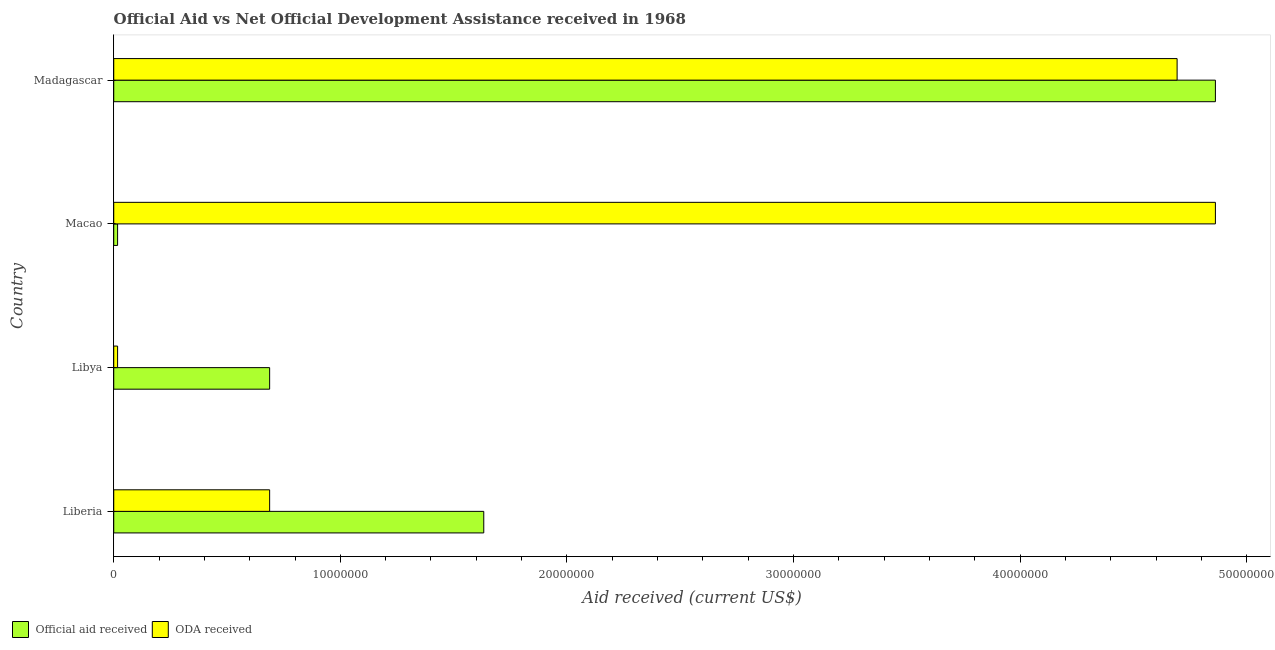Are the number of bars on each tick of the Y-axis equal?
Your answer should be compact. Yes. How many bars are there on the 4th tick from the bottom?
Make the answer very short. 2. What is the label of the 1st group of bars from the top?
Keep it short and to the point. Madagascar. In how many cases, is the number of bars for a given country not equal to the number of legend labels?
Keep it short and to the point. 0. What is the official aid received in Madagascar?
Make the answer very short. 4.86e+07. Across all countries, what is the maximum oda received?
Your response must be concise. 4.86e+07. Across all countries, what is the minimum official aid received?
Offer a very short reply. 1.70e+05. In which country was the official aid received maximum?
Make the answer very short. Madagascar. In which country was the oda received minimum?
Offer a very short reply. Libya. What is the total oda received in the graph?
Offer a terse response. 1.03e+08. What is the difference between the oda received in Liberia and that in Macao?
Your answer should be compact. -4.17e+07. What is the difference between the official aid received in Madagascar and the oda received in Liberia?
Your answer should be compact. 4.17e+07. What is the average official aid received per country?
Your answer should be very brief. 1.80e+07. What is the difference between the oda received and official aid received in Macao?
Give a very brief answer. 4.84e+07. What is the ratio of the oda received in Macao to that in Madagascar?
Offer a terse response. 1.04. Is the oda received in Liberia less than that in Libya?
Ensure brevity in your answer.  No. Is the difference between the official aid received in Liberia and Libya greater than the difference between the oda received in Liberia and Libya?
Your answer should be very brief. Yes. What is the difference between the highest and the second highest oda received?
Your answer should be compact. 1.69e+06. What is the difference between the highest and the lowest official aid received?
Make the answer very short. 4.84e+07. Is the sum of the official aid received in Macao and Madagascar greater than the maximum oda received across all countries?
Ensure brevity in your answer.  Yes. What does the 2nd bar from the top in Madagascar represents?
Offer a terse response. Official aid received. What does the 1st bar from the bottom in Madagascar represents?
Offer a terse response. Official aid received. How many bars are there?
Your response must be concise. 8. Are all the bars in the graph horizontal?
Keep it short and to the point. Yes. Are the values on the major ticks of X-axis written in scientific E-notation?
Offer a terse response. No. Does the graph contain grids?
Your answer should be compact. No. Where does the legend appear in the graph?
Your response must be concise. Bottom left. What is the title of the graph?
Keep it short and to the point. Official Aid vs Net Official Development Assistance received in 1968 . What is the label or title of the X-axis?
Make the answer very short. Aid received (current US$). What is the Aid received (current US$) of Official aid received in Liberia?
Provide a succinct answer. 1.63e+07. What is the Aid received (current US$) in ODA received in Liberia?
Your response must be concise. 6.88e+06. What is the Aid received (current US$) in Official aid received in Libya?
Keep it short and to the point. 6.88e+06. What is the Aid received (current US$) of ODA received in Macao?
Make the answer very short. 4.86e+07. What is the Aid received (current US$) of Official aid received in Madagascar?
Your answer should be compact. 4.86e+07. What is the Aid received (current US$) of ODA received in Madagascar?
Offer a terse response. 4.69e+07. Across all countries, what is the maximum Aid received (current US$) in Official aid received?
Your answer should be compact. 4.86e+07. Across all countries, what is the maximum Aid received (current US$) in ODA received?
Provide a short and direct response. 4.86e+07. Across all countries, what is the minimum Aid received (current US$) of ODA received?
Your answer should be compact. 1.70e+05. What is the total Aid received (current US$) of Official aid received in the graph?
Offer a very short reply. 7.20e+07. What is the total Aid received (current US$) of ODA received in the graph?
Offer a terse response. 1.03e+08. What is the difference between the Aid received (current US$) of Official aid received in Liberia and that in Libya?
Make the answer very short. 9.45e+06. What is the difference between the Aid received (current US$) of ODA received in Liberia and that in Libya?
Keep it short and to the point. 6.71e+06. What is the difference between the Aid received (current US$) in Official aid received in Liberia and that in Macao?
Ensure brevity in your answer.  1.62e+07. What is the difference between the Aid received (current US$) of ODA received in Liberia and that in Macao?
Ensure brevity in your answer.  -4.17e+07. What is the difference between the Aid received (current US$) of Official aid received in Liberia and that in Madagascar?
Your response must be concise. -3.23e+07. What is the difference between the Aid received (current US$) in ODA received in Liberia and that in Madagascar?
Your answer should be very brief. -4.00e+07. What is the difference between the Aid received (current US$) of Official aid received in Libya and that in Macao?
Offer a very short reply. 6.71e+06. What is the difference between the Aid received (current US$) in ODA received in Libya and that in Macao?
Provide a succinct answer. -4.84e+07. What is the difference between the Aid received (current US$) in Official aid received in Libya and that in Madagascar?
Provide a succinct answer. -4.17e+07. What is the difference between the Aid received (current US$) of ODA received in Libya and that in Madagascar?
Give a very brief answer. -4.68e+07. What is the difference between the Aid received (current US$) of Official aid received in Macao and that in Madagascar?
Ensure brevity in your answer.  -4.84e+07. What is the difference between the Aid received (current US$) of ODA received in Macao and that in Madagascar?
Ensure brevity in your answer.  1.69e+06. What is the difference between the Aid received (current US$) in Official aid received in Liberia and the Aid received (current US$) in ODA received in Libya?
Provide a succinct answer. 1.62e+07. What is the difference between the Aid received (current US$) in Official aid received in Liberia and the Aid received (current US$) in ODA received in Macao?
Ensure brevity in your answer.  -3.23e+07. What is the difference between the Aid received (current US$) of Official aid received in Liberia and the Aid received (current US$) of ODA received in Madagascar?
Your answer should be compact. -3.06e+07. What is the difference between the Aid received (current US$) of Official aid received in Libya and the Aid received (current US$) of ODA received in Macao?
Your answer should be very brief. -4.17e+07. What is the difference between the Aid received (current US$) in Official aid received in Libya and the Aid received (current US$) in ODA received in Madagascar?
Your answer should be very brief. -4.00e+07. What is the difference between the Aid received (current US$) of Official aid received in Macao and the Aid received (current US$) of ODA received in Madagascar?
Provide a short and direct response. -4.68e+07. What is the average Aid received (current US$) in Official aid received per country?
Offer a very short reply. 1.80e+07. What is the average Aid received (current US$) of ODA received per country?
Offer a very short reply. 2.56e+07. What is the difference between the Aid received (current US$) in Official aid received and Aid received (current US$) in ODA received in Liberia?
Your response must be concise. 9.45e+06. What is the difference between the Aid received (current US$) in Official aid received and Aid received (current US$) in ODA received in Libya?
Your answer should be compact. 6.71e+06. What is the difference between the Aid received (current US$) in Official aid received and Aid received (current US$) in ODA received in Macao?
Offer a very short reply. -4.84e+07. What is the difference between the Aid received (current US$) of Official aid received and Aid received (current US$) of ODA received in Madagascar?
Your answer should be very brief. 1.69e+06. What is the ratio of the Aid received (current US$) of Official aid received in Liberia to that in Libya?
Provide a short and direct response. 2.37. What is the ratio of the Aid received (current US$) of ODA received in Liberia to that in Libya?
Make the answer very short. 40.47. What is the ratio of the Aid received (current US$) in Official aid received in Liberia to that in Macao?
Your response must be concise. 96.06. What is the ratio of the Aid received (current US$) of ODA received in Liberia to that in Macao?
Your answer should be compact. 0.14. What is the ratio of the Aid received (current US$) in Official aid received in Liberia to that in Madagascar?
Ensure brevity in your answer.  0.34. What is the ratio of the Aid received (current US$) in ODA received in Liberia to that in Madagascar?
Make the answer very short. 0.15. What is the ratio of the Aid received (current US$) in Official aid received in Libya to that in Macao?
Give a very brief answer. 40.47. What is the ratio of the Aid received (current US$) of ODA received in Libya to that in Macao?
Keep it short and to the point. 0. What is the ratio of the Aid received (current US$) in Official aid received in Libya to that in Madagascar?
Your response must be concise. 0.14. What is the ratio of the Aid received (current US$) of ODA received in Libya to that in Madagascar?
Ensure brevity in your answer.  0. What is the ratio of the Aid received (current US$) of Official aid received in Macao to that in Madagascar?
Keep it short and to the point. 0. What is the ratio of the Aid received (current US$) of ODA received in Macao to that in Madagascar?
Keep it short and to the point. 1.04. What is the difference between the highest and the second highest Aid received (current US$) of Official aid received?
Provide a short and direct response. 3.23e+07. What is the difference between the highest and the second highest Aid received (current US$) of ODA received?
Offer a very short reply. 1.69e+06. What is the difference between the highest and the lowest Aid received (current US$) of Official aid received?
Keep it short and to the point. 4.84e+07. What is the difference between the highest and the lowest Aid received (current US$) in ODA received?
Offer a very short reply. 4.84e+07. 